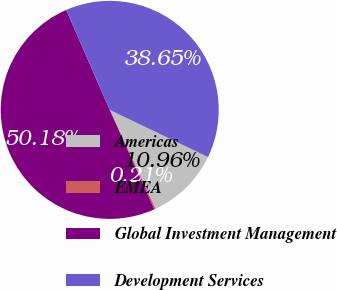<chart> <loc_0><loc_0><loc_500><loc_500><pie_chart><fcel>Americas<fcel>EMEA<fcel>Global Investment Management<fcel>Development Services<nl><fcel>10.96%<fcel>0.21%<fcel>50.18%<fcel>38.65%<nl></chart> 